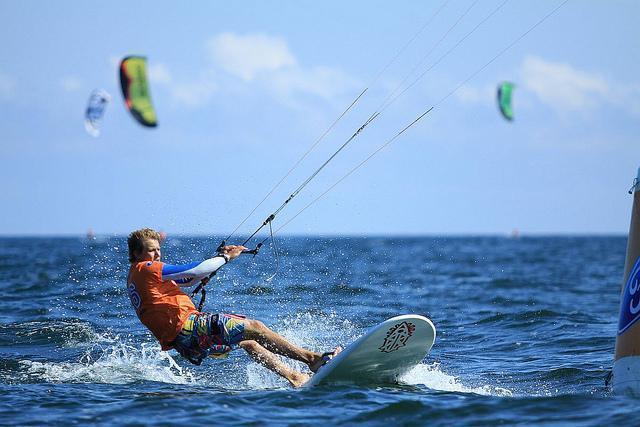The man who received the first patent for this sport was from which country?
Choose the correct response, then elucidate: 'Answer: answer
Rationale: rationale.'
Options: Australia, togo, lithuania, netherlands. Answer: netherlands.
Rationale: He was from the netherlands. 